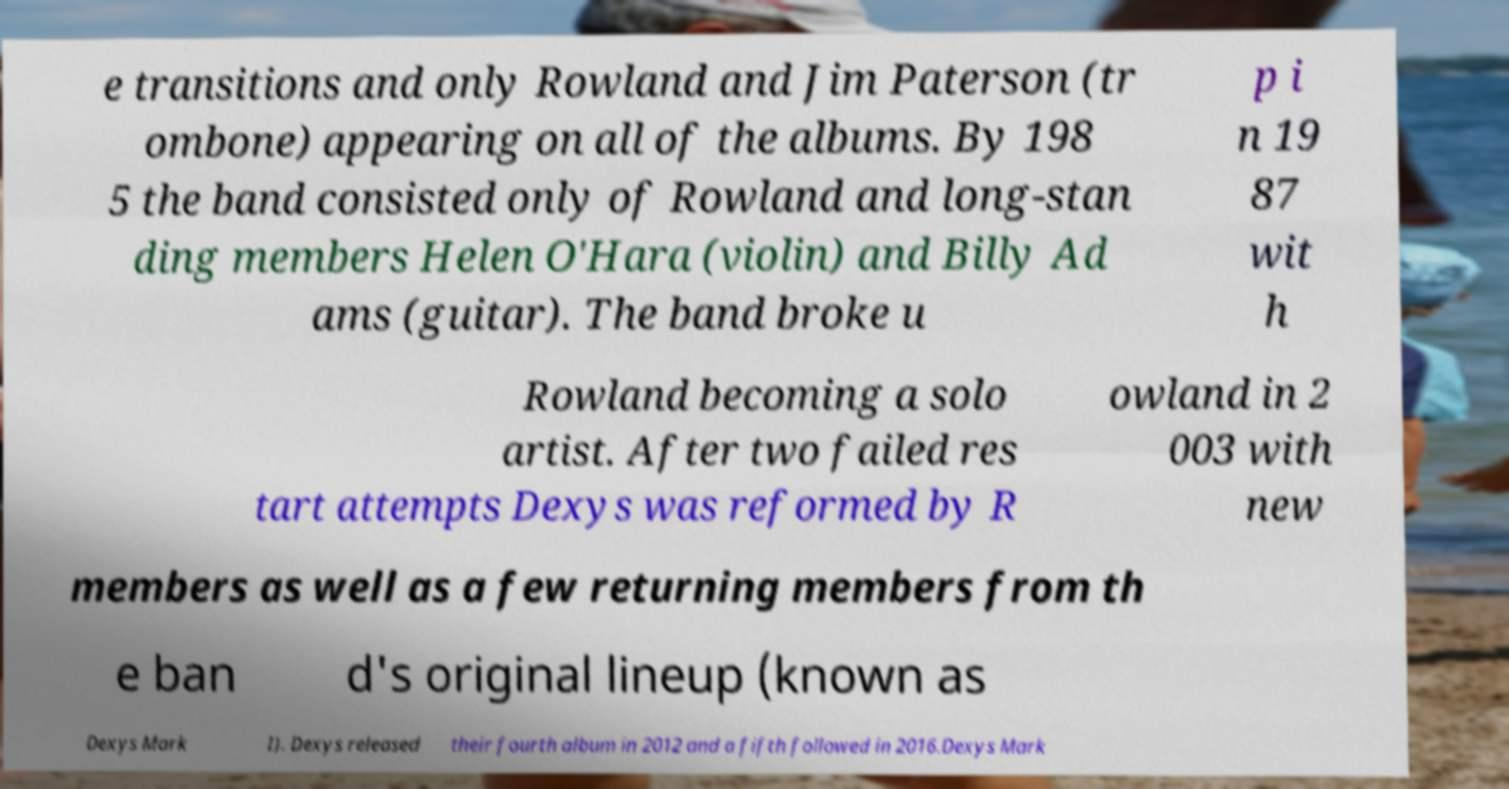For documentation purposes, I need the text within this image transcribed. Could you provide that? e transitions and only Rowland and Jim Paterson (tr ombone) appearing on all of the albums. By 198 5 the band consisted only of Rowland and long-stan ding members Helen O'Hara (violin) and Billy Ad ams (guitar). The band broke u p i n 19 87 wit h Rowland becoming a solo artist. After two failed res tart attempts Dexys was reformed by R owland in 2 003 with new members as well as a few returning members from th e ban d's original lineup (known as Dexys Mark I). Dexys released their fourth album in 2012 and a fifth followed in 2016.Dexys Mark 